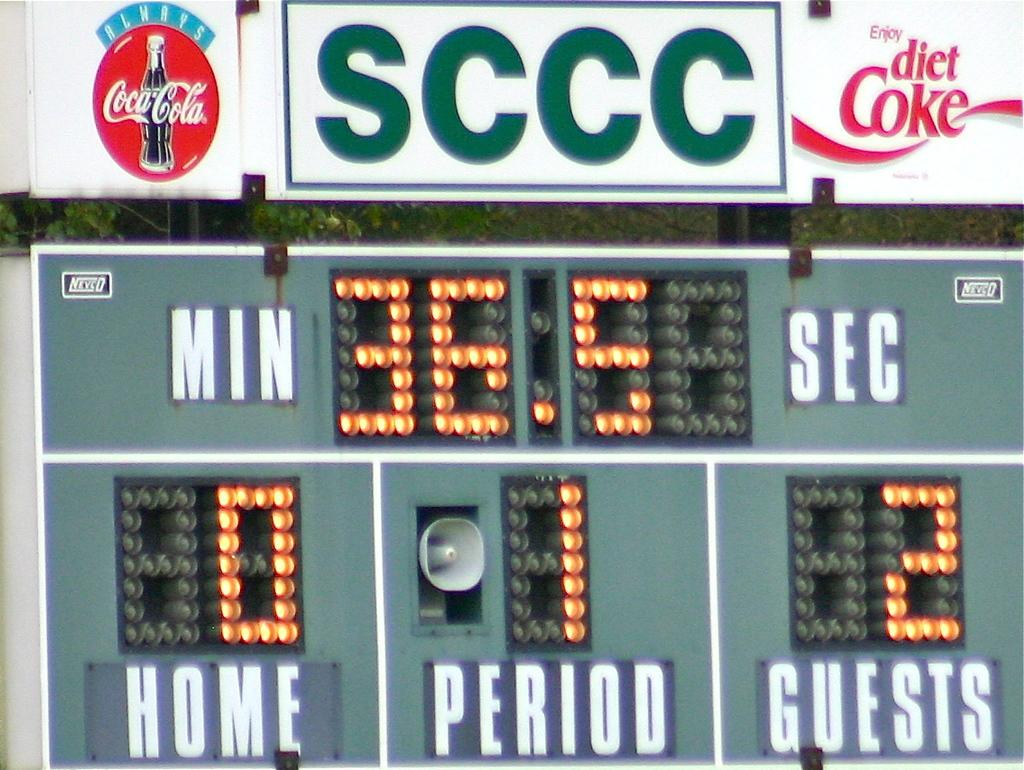What is the home teams score?
Your response must be concise. 0. How much time is left in the game?
Provide a succinct answer. 36.5. 